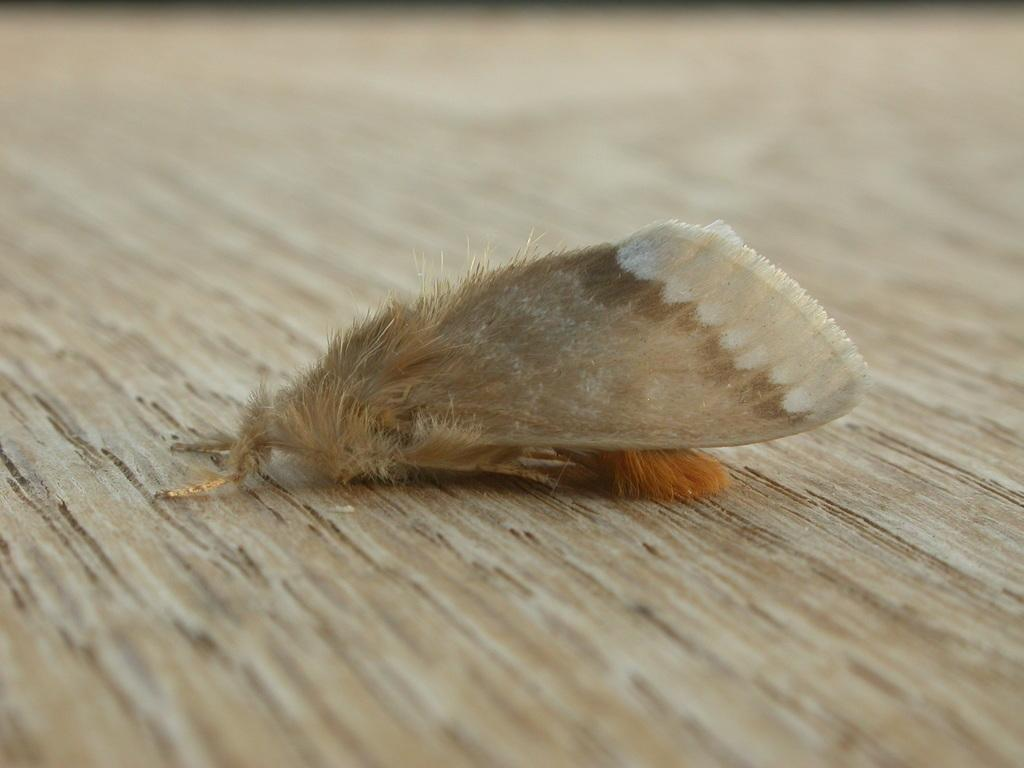What type of insect is in the image? There is a moth in the image. What surface is the moth on? The moth is on a wooden surface. What type of insurance policy is the moth considering in the image? There is no indication in the image that the moth is considering any insurance policy. What type of scarecrow is present in the image? There is no scarecrow present in the image. 